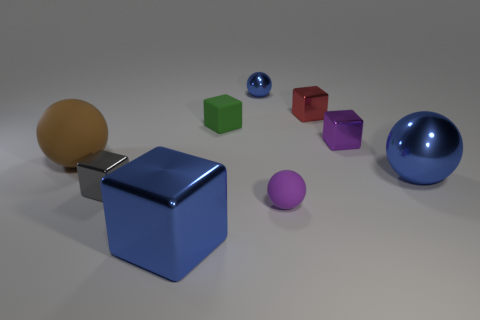Subtract 1 spheres. How many spheres are left? 3 Subtract all gray blocks. How many blocks are left? 4 Subtract all gray cubes. How many cubes are left? 4 Subtract all red blocks. Subtract all brown spheres. How many blocks are left? 4 Add 1 small purple rubber spheres. How many objects exist? 10 Subtract all cubes. How many objects are left? 4 Subtract all tiny yellow matte things. Subtract all blue metal things. How many objects are left? 6 Add 2 brown matte things. How many brown matte things are left? 3 Add 2 cubes. How many cubes exist? 7 Subtract 0 brown cylinders. How many objects are left? 9 